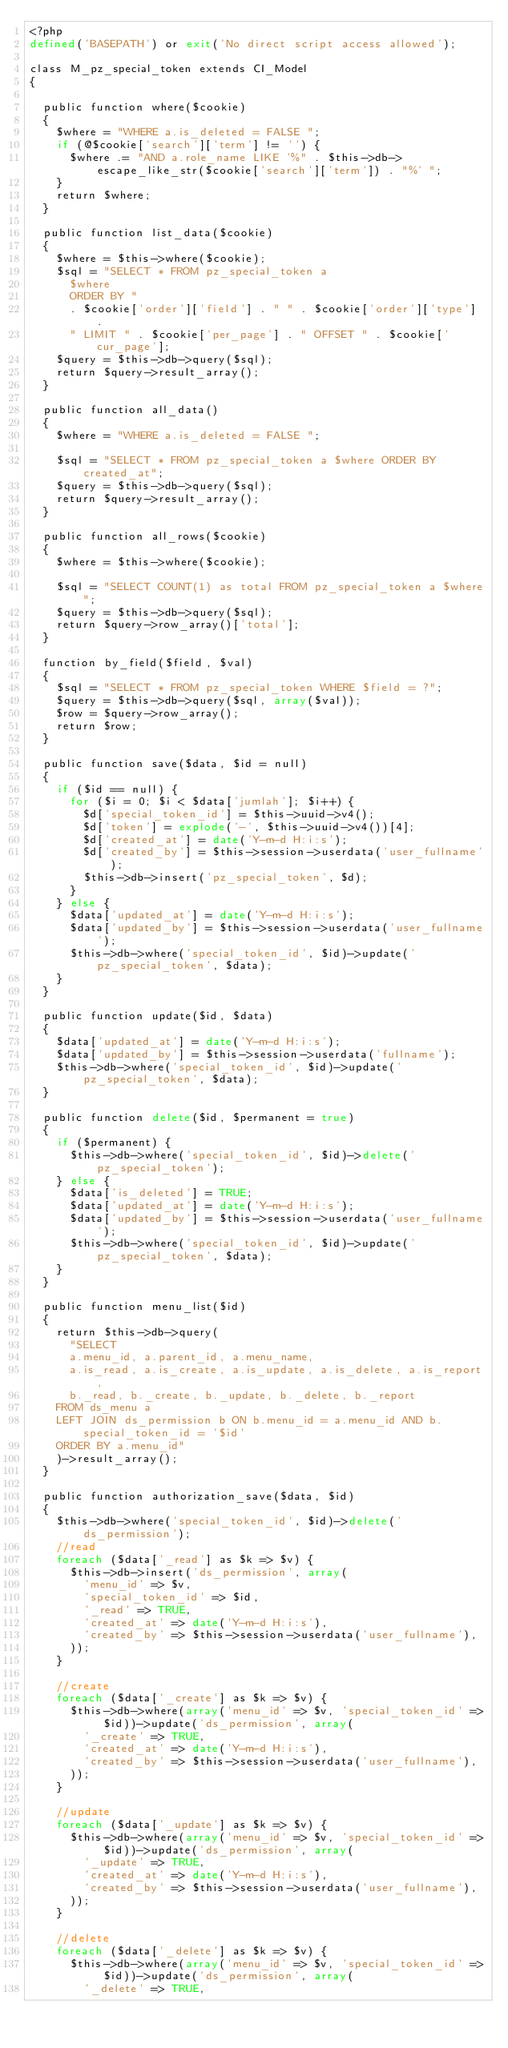<code> <loc_0><loc_0><loc_500><loc_500><_PHP_><?php
defined('BASEPATH') or exit('No direct script access allowed');

class M_pz_special_token extends CI_Model
{

  public function where($cookie)
  {
    $where = "WHERE a.is_deleted = FALSE ";
    if (@$cookie['search']['term'] != '') {
      $where .= "AND a.role_name LIKE '%" . $this->db->escape_like_str($cookie['search']['term']) . "%' ";
    }
    return $where;
  }

  public function list_data($cookie)
  {
    $where = $this->where($cookie);
    $sql = "SELECT * FROM pz_special_token a 
      $where
      ORDER BY "
      . $cookie['order']['field'] . " " . $cookie['order']['type'] .
      " LIMIT " . $cookie['per_page'] . " OFFSET " . $cookie['cur_page'];
    $query = $this->db->query($sql);
    return $query->result_array();
  }

  public function all_data()
  {
    $where = "WHERE a.is_deleted = FALSE ";

    $sql = "SELECT * FROM pz_special_token a $where ORDER BY created_at";
    $query = $this->db->query($sql);
    return $query->result_array();
  }

  public function all_rows($cookie)
  {
    $where = $this->where($cookie);

    $sql = "SELECT COUNT(1) as total FROM pz_special_token a $where";
    $query = $this->db->query($sql);
    return $query->row_array()['total'];
  }

  function by_field($field, $val)
  {
    $sql = "SELECT * FROM pz_special_token WHERE $field = ?";
    $query = $this->db->query($sql, array($val));
    $row = $query->row_array();
    return $row;
  }

  public function save($data, $id = null)
  {
    if ($id == null) {
      for ($i = 0; $i < $data['jumlah']; $i++) {
        $d['special_token_id'] = $this->uuid->v4();
        $d['token'] = explode('-', $this->uuid->v4())[4];
        $d['created_at'] = date('Y-m-d H:i:s');
        $d['created_by'] = $this->session->userdata('user_fullname');
        $this->db->insert('pz_special_token', $d);
      }
    } else {
      $data['updated_at'] = date('Y-m-d H:i:s');
      $data['updated_by'] = $this->session->userdata('user_fullname');
      $this->db->where('special_token_id', $id)->update('pz_special_token', $data);
    }
  }

  public function update($id, $data)
  {
    $data['updated_at'] = date('Y-m-d H:i:s');
    $data['updated_by'] = $this->session->userdata('fullname');
    $this->db->where('special_token_id', $id)->update('pz_special_token', $data);
  }

  public function delete($id, $permanent = true)
  {
    if ($permanent) {
      $this->db->where('special_token_id', $id)->delete('pz_special_token');
    } else {
      $data['is_deleted'] = TRUE;
      $data['updated_at'] = date('Y-m-d H:i:s');
      $data['updated_by'] = $this->session->userdata('user_fullname');
      $this->db->where('special_token_id', $id)->update('pz_special_token', $data);
    }
  }

  public function menu_list($id)
  {
    return $this->db->query(
      "SELECT 
      a.menu_id, a.parent_id, a.menu_name, 
      a.is_read, a.is_create, a.is_update, a.is_delete, a.is_report,
      b._read, b._create, b._update, b._delete, b._report
    FROM ds_menu a
    LEFT JOIN ds_permission b ON b.menu_id = a.menu_id AND b.special_token_id = '$id'
    ORDER BY a.menu_id"
    )->result_array();
  }

  public function authorization_save($data, $id)
  {
    $this->db->where('special_token_id', $id)->delete('ds_permission');
    //read
    foreach ($data['_read'] as $k => $v) {
      $this->db->insert('ds_permission', array(
        'menu_id' => $v,
        'special_token_id' => $id,
        '_read' => TRUE,
        'created_at' => date('Y-m-d H:i:s'),
        'created_by' => $this->session->userdata('user_fullname'),
      ));
    }

    //create
    foreach ($data['_create'] as $k => $v) {
      $this->db->where(array('menu_id' => $v, 'special_token_id' => $id))->update('ds_permission', array(
        '_create' => TRUE,
        'created_at' => date('Y-m-d H:i:s'),
        'created_by' => $this->session->userdata('user_fullname'),
      ));
    }

    //update
    foreach ($data['_update'] as $k => $v) {
      $this->db->where(array('menu_id' => $v, 'special_token_id' => $id))->update('ds_permission', array(
        '_update' => TRUE,
        'created_at' => date('Y-m-d H:i:s'),
        'created_by' => $this->session->userdata('user_fullname'),
      ));
    }

    //delete
    foreach ($data['_delete'] as $k => $v) {
      $this->db->where(array('menu_id' => $v, 'special_token_id' => $id))->update('ds_permission', array(
        '_delete' => TRUE,</code> 